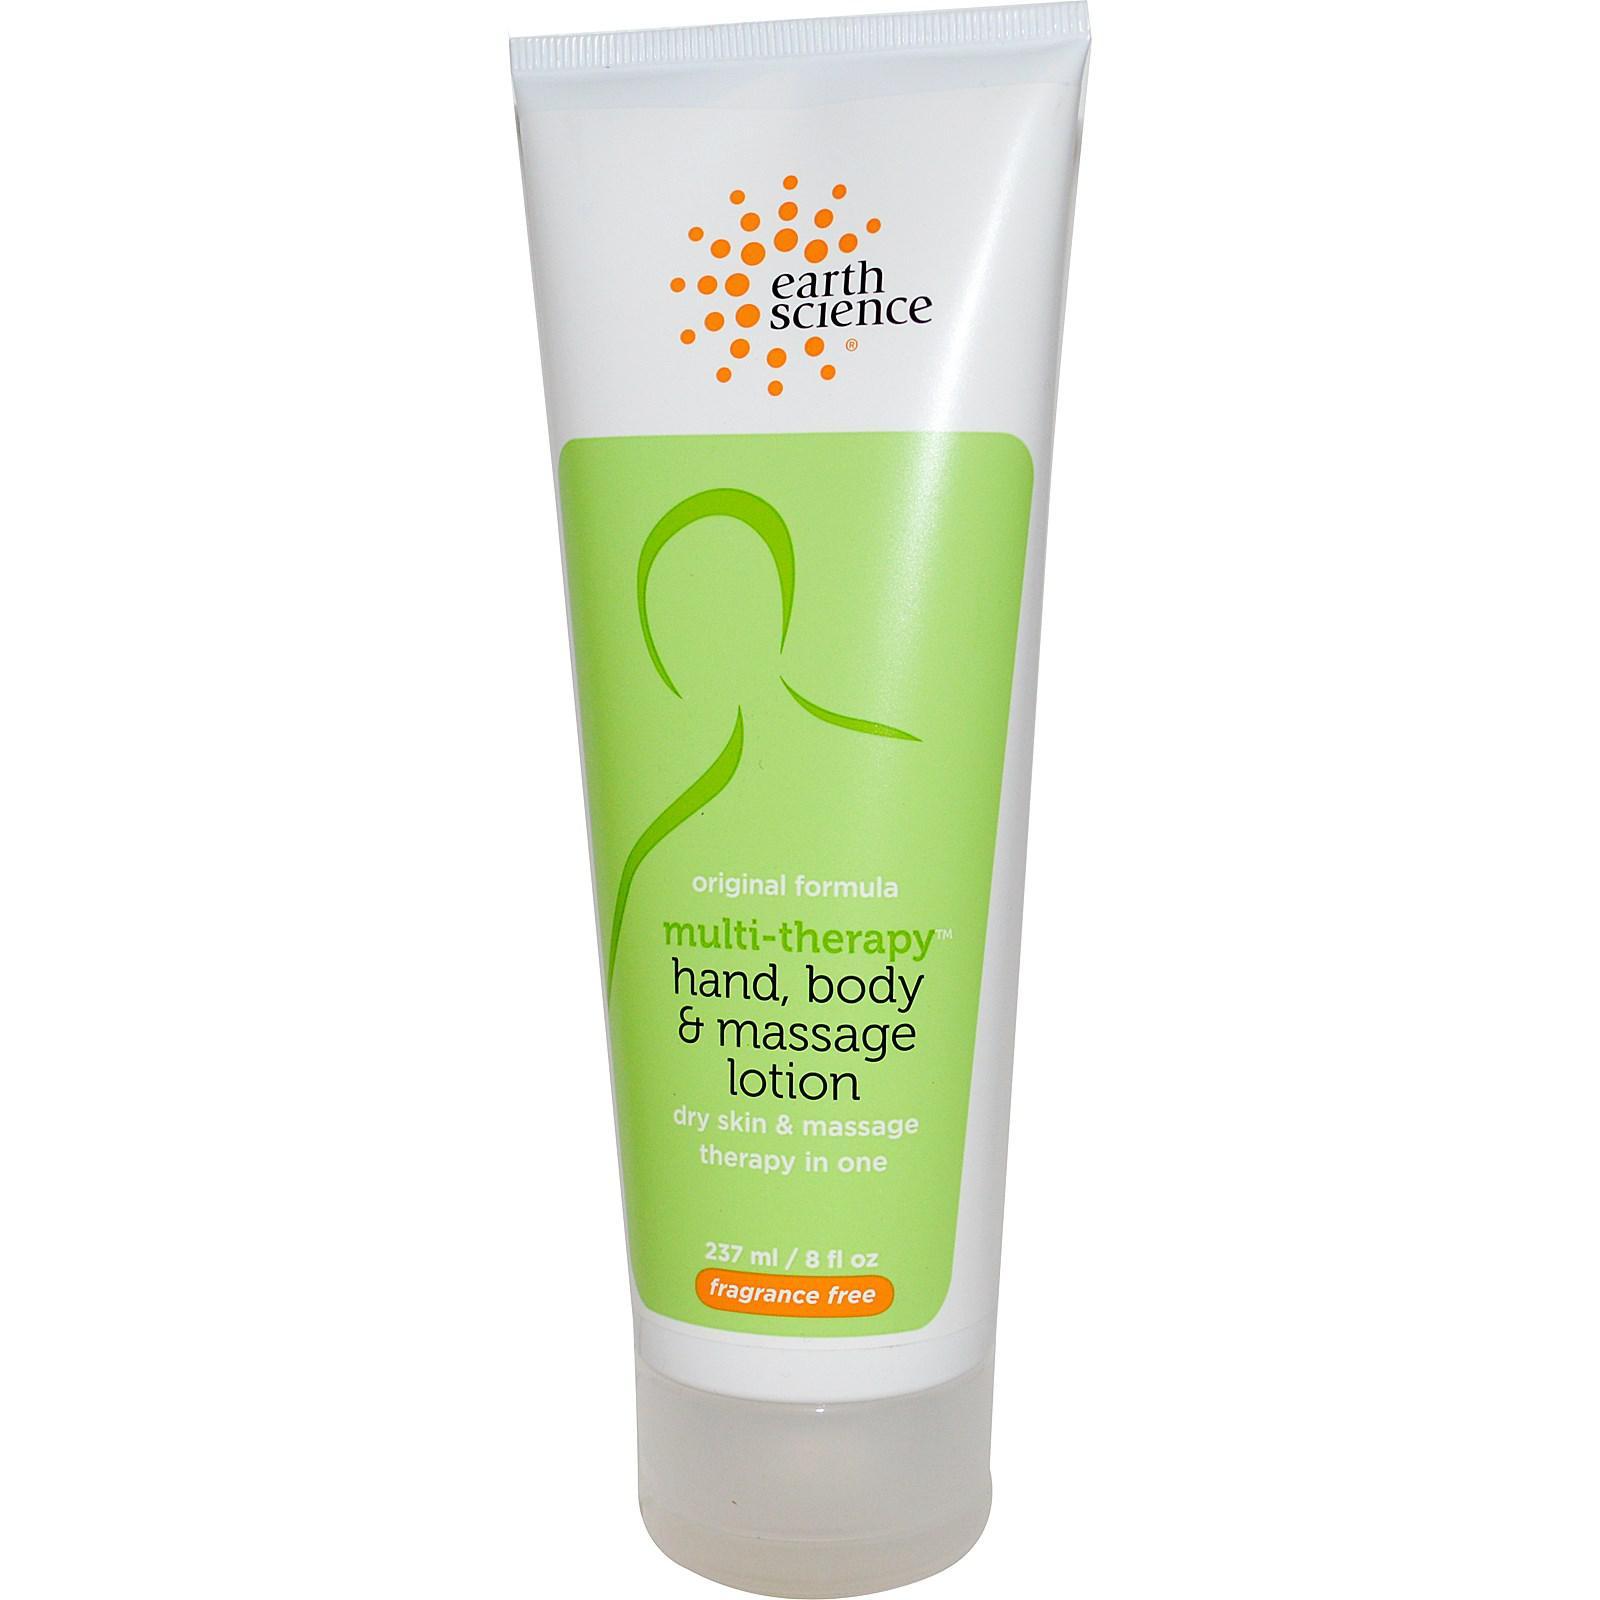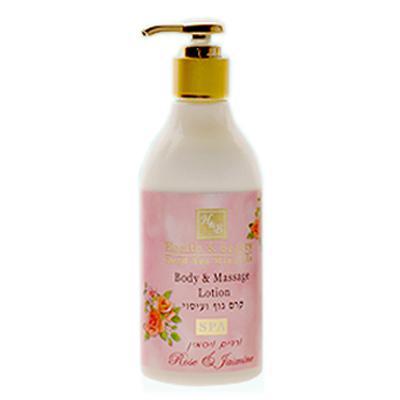The first image is the image on the left, the second image is the image on the right. For the images shown, is this caption "At least one bottle of body lotion has a pump top." true? Answer yes or no. Yes. The first image is the image on the left, the second image is the image on the right. Examine the images to the left and right. Is the description "Each image contains one skincare product on white background." accurate? Answer yes or no. Yes. 